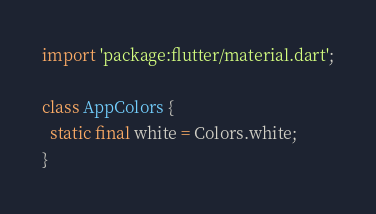<code> <loc_0><loc_0><loc_500><loc_500><_Dart_>import 'package:flutter/material.dart';

class AppColors {
  static final white = Colors.white;
}
</code> 